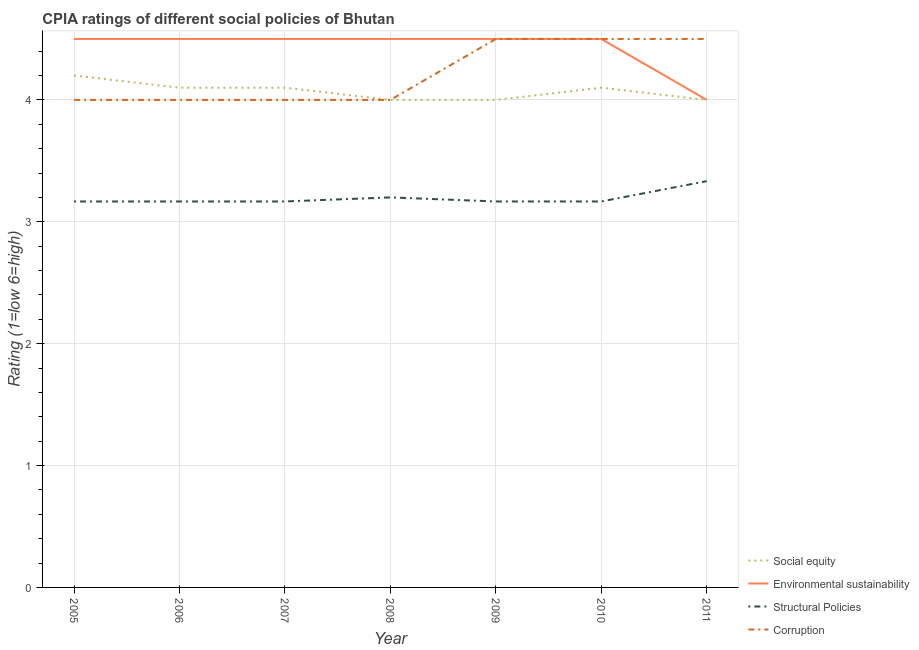How many different coloured lines are there?
Your response must be concise. 4. Does the line corresponding to cpia rating of environmental sustainability intersect with the line corresponding to cpia rating of social equity?
Your answer should be compact. Yes. Is the number of lines equal to the number of legend labels?
Offer a very short reply. Yes. What is the difference between the cpia rating of social equity in 2005 and that in 2009?
Your response must be concise. 0.2. What is the difference between the cpia rating of environmental sustainability in 2009 and the cpia rating of corruption in 2008?
Give a very brief answer. 0.5. What is the average cpia rating of structural policies per year?
Offer a very short reply. 3.2. In the year 2006, what is the difference between the cpia rating of social equity and cpia rating of environmental sustainability?
Your answer should be compact. -0.4. What is the difference between the highest and the second highest cpia rating of structural policies?
Give a very brief answer. 0.13. What is the difference between the highest and the lowest cpia rating of corruption?
Your answer should be compact. 0.5. In how many years, is the cpia rating of environmental sustainability greater than the average cpia rating of environmental sustainability taken over all years?
Provide a short and direct response. 6. Is it the case that in every year, the sum of the cpia rating of structural policies and cpia rating of environmental sustainability is greater than the sum of cpia rating of corruption and cpia rating of social equity?
Your answer should be compact. Yes. Is it the case that in every year, the sum of the cpia rating of social equity and cpia rating of environmental sustainability is greater than the cpia rating of structural policies?
Your response must be concise. Yes. Is the cpia rating of environmental sustainability strictly less than the cpia rating of social equity over the years?
Offer a terse response. No. How many lines are there?
Give a very brief answer. 4. How many years are there in the graph?
Your response must be concise. 7. How are the legend labels stacked?
Your answer should be very brief. Vertical. What is the title of the graph?
Provide a short and direct response. CPIA ratings of different social policies of Bhutan. Does "Public sector management" appear as one of the legend labels in the graph?
Your answer should be compact. No. What is the label or title of the X-axis?
Offer a terse response. Year. What is the label or title of the Y-axis?
Offer a terse response. Rating (1=low 6=high). What is the Rating (1=low 6=high) of Environmental sustainability in 2005?
Your answer should be very brief. 4.5. What is the Rating (1=low 6=high) of Structural Policies in 2005?
Offer a terse response. 3.17. What is the Rating (1=low 6=high) of Social equity in 2006?
Offer a terse response. 4.1. What is the Rating (1=low 6=high) in Environmental sustainability in 2006?
Provide a short and direct response. 4.5. What is the Rating (1=low 6=high) of Structural Policies in 2006?
Ensure brevity in your answer.  3.17. What is the Rating (1=low 6=high) in Corruption in 2006?
Your response must be concise. 4. What is the Rating (1=low 6=high) of Environmental sustainability in 2007?
Make the answer very short. 4.5. What is the Rating (1=low 6=high) of Structural Policies in 2007?
Provide a succinct answer. 3.17. What is the Rating (1=low 6=high) in Corruption in 2007?
Your answer should be compact. 4. What is the Rating (1=low 6=high) in Social equity in 2008?
Offer a terse response. 4. What is the Rating (1=low 6=high) in Environmental sustainability in 2008?
Offer a terse response. 4.5. What is the Rating (1=low 6=high) in Structural Policies in 2008?
Your response must be concise. 3.2. What is the Rating (1=low 6=high) in Structural Policies in 2009?
Keep it short and to the point. 3.17. What is the Rating (1=low 6=high) in Social equity in 2010?
Your answer should be very brief. 4.1. What is the Rating (1=low 6=high) in Environmental sustainability in 2010?
Your answer should be very brief. 4.5. What is the Rating (1=low 6=high) in Structural Policies in 2010?
Give a very brief answer. 3.17. What is the Rating (1=low 6=high) of Social equity in 2011?
Offer a very short reply. 4. What is the Rating (1=low 6=high) in Environmental sustainability in 2011?
Your response must be concise. 4. What is the Rating (1=low 6=high) in Structural Policies in 2011?
Provide a short and direct response. 3.33. Across all years, what is the maximum Rating (1=low 6=high) in Environmental sustainability?
Offer a very short reply. 4.5. Across all years, what is the maximum Rating (1=low 6=high) in Structural Policies?
Provide a succinct answer. 3.33. Across all years, what is the maximum Rating (1=low 6=high) in Corruption?
Offer a terse response. 4.5. Across all years, what is the minimum Rating (1=low 6=high) of Environmental sustainability?
Offer a terse response. 4. Across all years, what is the minimum Rating (1=low 6=high) in Structural Policies?
Ensure brevity in your answer.  3.17. What is the total Rating (1=low 6=high) in Social equity in the graph?
Your answer should be compact. 28.5. What is the total Rating (1=low 6=high) of Structural Policies in the graph?
Offer a terse response. 22.37. What is the total Rating (1=low 6=high) of Corruption in the graph?
Provide a short and direct response. 29.5. What is the difference between the Rating (1=low 6=high) of Social equity in 2005 and that in 2006?
Your answer should be very brief. 0.1. What is the difference between the Rating (1=low 6=high) of Environmental sustainability in 2005 and that in 2006?
Ensure brevity in your answer.  0. What is the difference between the Rating (1=low 6=high) of Corruption in 2005 and that in 2006?
Make the answer very short. 0. What is the difference between the Rating (1=low 6=high) in Social equity in 2005 and that in 2007?
Provide a short and direct response. 0.1. What is the difference between the Rating (1=low 6=high) of Environmental sustainability in 2005 and that in 2007?
Ensure brevity in your answer.  0. What is the difference between the Rating (1=low 6=high) in Structural Policies in 2005 and that in 2007?
Provide a short and direct response. 0. What is the difference between the Rating (1=low 6=high) of Social equity in 2005 and that in 2008?
Offer a very short reply. 0.2. What is the difference between the Rating (1=low 6=high) in Environmental sustainability in 2005 and that in 2008?
Give a very brief answer. 0. What is the difference between the Rating (1=low 6=high) in Structural Policies in 2005 and that in 2008?
Provide a succinct answer. -0.03. What is the difference between the Rating (1=low 6=high) in Structural Policies in 2005 and that in 2009?
Your answer should be compact. 0. What is the difference between the Rating (1=low 6=high) in Corruption in 2005 and that in 2009?
Your answer should be very brief. -0.5. What is the difference between the Rating (1=low 6=high) in Social equity in 2005 and that in 2011?
Ensure brevity in your answer.  0.2. What is the difference between the Rating (1=low 6=high) in Environmental sustainability in 2005 and that in 2011?
Offer a terse response. 0.5. What is the difference between the Rating (1=low 6=high) of Social equity in 2006 and that in 2007?
Offer a terse response. 0. What is the difference between the Rating (1=low 6=high) in Structural Policies in 2006 and that in 2008?
Ensure brevity in your answer.  -0.03. What is the difference between the Rating (1=low 6=high) in Corruption in 2006 and that in 2008?
Ensure brevity in your answer.  0. What is the difference between the Rating (1=low 6=high) of Social equity in 2006 and that in 2009?
Offer a very short reply. 0.1. What is the difference between the Rating (1=low 6=high) of Structural Policies in 2006 and that in 2009?
Your answer should be compact. 0. What is the difference between the Rating (1=low 6=high) in Corruption in 2006 and that in 2009?
Provide a short and direct response. -0.5. What is the difference between the Rating (1=low 6=high) in Environmental sustainability in 2006 and that in 2010?
Make the answer very short. 0. What is the difference between the Rating (1=low 6=high) in Structural Policies in 2006 and that in 2010?
Your answer should be compact. 0. What is the difference between the Rating (1=low 6=high) of Social equity in 2006 and that in 2011?
Your response must be concise. 0.1. What is the difference between the Rating (1=low 6=high) in Structural Policies in 2006 and that in 2011?
Give a very brief answer. -0.17. What is the difference between the Rating (1=low 6=high) in Social equity in 2007 and that in 2008?
Ensure brevity in your answer.  0.1. What is the difference between the Rating (1=low 6=high) of Structural Policies in 2007 and that in 2008?
Your answer should be compact. -0.03. What is the difference between the Rating (1=low 6=high) of Environmental sustainability in 2007 and that in 2009?
Provide a short and direct response. 0. What is the difference between the Rating (1=low 6=high) in Structural Policies in 2007 and that in 2009?
Provide a succinct answer. 0. What is the difference between the Rating (1=low 6=high) of Corruption in 2007 and that in 2009?
Your response must be concise. -0.5. What is the difference between the Rating (1=low 6=high) of Social equity in 2007 and that in 2010?
Ensure brevity in your answer.  0. What is the difference between the Rating (1=low 6=high) in Environmental sustainability in 2007 and that in 2010?
Offer a terse response. 0. What is the difference between the Rating (1=low 6=high) of Corruption in 2007 and that in 2011?
Keep it short and to the point. -0.5. What is the difference between the Rating (1=low 6=high) of Social equity in 2008 and that in 2009?
Your answer should be compact. 0. What is the difference between the Rating (1=low 6=high) in Structural Policies in 2008 and that in 2009?
Your response must be concise. 0.03. What is the difference between the Rating (1=low 6=high) in Environmental sustainability in 2008 and that in 2010?
Provide a succinct answer. 0. What is the difference between the Rating (1=low 6=high) of Social equity in 2008 and that in 2011?
Keep it short and to the point. 0. What is the difference between the Rating (1=low 6=high) in Environmental sustainability in 2008 and that in 2011?
Ensure brevity in your answer.  0.5. What is the difference between the Rating (1=low 6=high) in Structural Policies in 2008 and that in 2011?
Ensure brevity in your answer.  -0.13. What is the difference between the Rating (1=low 6=high) of Social equity in 2009 and that in 2010?
Provide a short and direct response. -0.1. What is the difference between the Rating (1=low 6=high) in Environmental sustainability in 2009 and that in 2010?
Give a very brief answer. 0. What is the difference between the Rating (1=low 6=high) of Structural Policies in 2009 and that in 2010?
Give a very brief answer. 0. What is the difference between the Rating (1=low 6=high) of Corruption in 2009 and that in 2010?
Ensure brevity in your answer.  0. What is the difference between the Rating (1=low 6=high) in Environmental sustainability in 2010 and that in 2011?
Your response must be concise. 0.5. What is the difference between the Rating (1=low 6=high) in Social equity in 2005 and the Rating (1=low 6=high) in Environmental sustainability in 2006?
Offer a very short reply. -0.3. What is the difference between the Rating (1=low 6=high) of Social equity in 2005 and the Rating (1=low 6=high) of Structural Policies in 2006?
Make the answer very short. 1.03. What is the difference between the Rating (1=low 6=high) of Environmental sustainability in 2005 and the Rating (1=low 6=high) of Corruption in 2006?
Offer a terse response. 0.5. What is the difference between the Rating (1=low 6=high) in Structural Policies in 2005 and the Rating (1=low 6=high) in Corruption in 2006?
Keep it short and to the point. -0.83. What is the difference between the Rating (1=low 6=high) in Social equity in 2005 and the Rating (1=low 6=high) in Structural Policies in 2008?
Offer a very short reply. 1. What is the difference between the Rating (1=low 6=high) of Structural Policies in 2005 and the Rating (1=low 6=high) of Corruption in 2008?
Provide a succinct answer. -0.83. What is the difference between the Rating (1=low 6=high) in Social equity in 2005 and the Rating (1=low 6=high) in Structural Policies in 2009?
Ensure brevity in your answer.  1.03. What is the difference between the Rating (1=low 6=high) in Environmental sustainability in 2005 and the Rating (1=low 6=high) in Structural Policies in 2009?
Provide a succinct answer. 1.33. What is the difference between the Rating (1=low 6=high) in Structural Policies in 2005 and the Rating (1=low 6=high) in Corruption in 2009?
Your answer should be compact. -1.33. What is the difference between the Rating (1=low 6=high) in Social equity in 2005 and the Rating (1=low 6=high) in Corruption in 2010?
Give a very brief answer. -0.3. What is the difference between the Rating (1=low 6=high) in Environmental sustainability in 2005 and the Rating (1=low 6=high) in Corruption in 2010?
Keep it short and to the point. 0. What is the difference between the Rating (1=low 6=high) of Structural Policies in 2005 and the Rating (1=low 6=high) of Corruption in 2010?
Offer a very short reply. -1.33. What is the difference between the Rating (1=low 6=high) in Social equity in 2005 and the Rating (1=low 6=high) in Structural Policies in 2011?
Provide a succinct answer. 0.87. What is the difference between the Rating (1=low 6=high) of Structural Policies in 2005 and the Rating (1=low 6=high) of Corruption in 2011?
Offer a terse response. -1.33. What is the difference between the Rating (1=low 6=high) in Social equity in 2006 and the Rating (1=low 6=high) in Structural Policies in 2007?
Your answer should be compact. 0.93. What is the difference between the Rating (1=low 6=high) in Social equity in 2006 and the Rating (1=low 6=high) in Corruption in 2007?
Give a very brief answer. 0.1. What is the difference between the Rating (1=low 6=high) in Environmental sustainability in 2006 and the Rating (1=low 6=high) in Structural Policies in 2007?
Give a very brief answer. 1.33. What is the difference between the Rating (1=low 6=high) of Social equity in 2006 and the Rating (1=low 6=high) of Corruption in 2009?
Offer a very short reply. -0.4. What is the difference between the Rating (1=low 6=high) in Structural Policies in 2006 and the Rating (1=low 6=high) in Corruption in 2009?
Offer a very short reply. -1.33. What is the difference between the Rating (1=low 6=high) in Social equity in 2006 and the Rating (1=low 6=high) in Environmental sustainability in 2010?
Offer a very short reply. -0.4. What is the difference between the Rating (1=low 6=high) of Social equity in 2006 and the Rating (1=low 6=high) of Structural Policies in 2010?
Keep it short and to the point. 0.93. What is the difference between the Rating (1=low 6=high) in Social equity in 2006 and the Rating (1=low 6=high) in Corruption in 2010?
Provide a short and direct response. -0.4. What is the difference between the Rating (1=low 6=high) of Environmental sustainability in 2006 and the Rating (1=low 6=high) of Structural Policies in 2010?
Your response must be concise. 1.33. What is the difference between the Rating (1=low 6=high) in Structural Policies in 2006 and the Rating (1=low 6=high) in Corruption in 2010?
Your answer should be very brief. -1.33. What is the difference between the Rating (1=low 6=high) of Social equity in 2006 and the Rating (1=low 6=high) of Environmental sustainability in 2011?
Give a very brief answer. 0.1. What is the difference between the Rating (1=low 6=high) in Social equity in 2006 and the Rating (1=low 6=high) in Structural Policies in 2011?
Offer a very short reply. 0.77. What is the difference between the Rating (1=low 6=high) in Environmental sustainability in 2006 and the Rating (1=low 6=high) in Structural Policies in 2011?
Provide a short and direct response. 1.17. What is the difference between the Rating (1=low 6=high) in Structural Policies in 2006 and the Rating (1=low 6=high) in Corruption in 2011?
Give a very brief answer. -1.33. What is the difference between the Rating (1=low 6=high) in Social equity in 2007 and the Rating (1=low 6=high) in Structural Policies in 2008?
Offer a terse response. 0.9. What is the difference between the Rating (1=low 6=high) in Social equity in 2007 and the Rating (1=low 6=high) in Corruption in 2008?
Make the answer very short. 0.1. What is the difference between the Rating (1=low 6=high) in Environmental sustainability in 2007 and the Rating (1=low 6=high) in Corruption in 2009?
Offer a very short reply. 0. What is the difference between the Rating (1=low 6=high) of Structural Policies in 2007 and the Rating (1=low 6=high) of Corruption in 2009?
Provide a short and direct response. -1.33. What is the difference between the Rating (1=low 6=high) of Structural Policies in 2007 and the Rating (1=low 6=high) of Corruption in 2010?
Your answer should be very brief. -1.33. What is the difference between the Rating (1=low 6=high) in Social equity in 2007 and the Rating (1=low 6=high) in Environmental sustainability in 2011?
Your answer should be very brief. 0.1. What is the difference between the Rating (1=low 6=high) in Social equity in 2007 and the Rating (1=low 6=high) in Structural Policies in 2011?
Your answer should be compact. 0.77. What is the difference between the Rating (1=low 6=high) in Social equity in 2007 and the Rating (1=low 6=high) in Corruption in 2011?
Provide a succinct answer. -0.4. What is the difference between the Rating (1=low 6=high) in Structural Policies in 2007 and the Rating (1=low 6=high) in Corruption in 2011?
Give a very brief answer. -1.33. What is the difference between the Rating (1=low 6=high) of Social equity in 2008 and the Rating (1=low 6=high) of Structural Policies in 2009?
Provide a short and direct response. 0.83. What is the difference between the Rating (1=low 6=high) of Environmental sustainability in 2008 and the Rating (1=low 6=high) of Corruption in 2009?
Provide a short and direct response. 0. What is the difference between the Rating (1=low 6=high) in Structural Policies in 2008 and the Rating (1=low 6=high) in Corruption in 2009?
Offer a terse response. -1.3. What is the difference between the Rating (1=low 6=high) in Social equity in 2008 and the Rating (1=low 6=high) in Structural Policies in 2010?
Provide a succinct answer. 0.83. What is the difference between the Rating (1=low 6=high) of Social equity in 2008 and the Rating (1=low 6=high) of Corruption in 2010?
Your response must be concise. -0.5. What is the difference between the Rating (1=low 6=high) of Social equity in 2008 and the Rating (1=low 6=high) of Environmental sustainability in 2011?
Offer a very short reply. 0. What is the difference between the Rating (1=low 6=high) in Social equity in 2008 and the Rating (1=low 6=high) in Structural Policies in 2011?
Your answer should be compact. 0.67. What is the difference between the Rating (1=low 6=high) of Social equity in 2009 and the Rating (1=low 6=high) of Environmental sustainability in 2010?
Offer a very short reply. -0.5. What is the difference between the Rating (1=low 6=high) in Social equity in 2009 and the Rating (1=low 6=high) in Structural Policies in 2010?
Provide a short and direct response. 0.83. What is the difference between the Rating (1=low 6=high) of Structural Policies in 2009 and the Rating (1=low 6=high) of Corruption in 2010?
Keep it short and to the point. -1.33. What is the difference between the Rating (1=low 6=high) in Social equity in 2009 and the Rating (1=low 6=high) in Environmental sustainability in 2011?
Your answer should be very brief. 0. What is the difference between the Rating (1=low 6=high) in Social equity in 2009 and the Rating (1=low 6=high) in Structural Policies in 2011?
Your answer should be very brief. 0.67. What is the difference between the Rating (1=low 6=high) of Environmental sustainability in 2009 and the Rating (1=low 6=high) of Structural Policies in 2011?
Provide a short and direct response. 1.17. What is the difference between the Rating (1=low 6=high) in Structural Policies in 2009 and the Rating (1=low 6=high) in Corruption in 2011?
Offer a terse response. -1.33. What is the difference between the Rating (1=low 6=high) in Social equity in 2010 and the Rating (1=low 6=high) in Structural Policies in 2011?
Provide a short and direct response. 0.77. What is the difference between the Rating (1=low 6=high) in Social equity in 2010 and the Rating (1=low 6=high) in Corruption in 2011?
Provide a succinct answer. -0.4. What is the difference between the Rating (1=low 6=high) of Environmental sustainability in 2010 and the Rating (1=low 6=high) of Corruption in 2011?
Offer a terse response. 0. What is the difference between the Rating (1=low 6=high) in Structural Policies in 2010 and the Rating (1=low 6=high) in Corruption in 2011?
Keep it short and to the point. -1.33. What is the average Rating (1=low 6=high) in Social equity per year?
Provide a succinct answer. 4.07. What is the average Rating (1=low 6=high) of Environmental sustainability per year?
Keep it short and to the point. 4.43. What is the average Rating (1=low 6=high) in Structural Policies per year?
Give a very brief answer. 3.2. What is the average Rating (1=low 6=high) of Corruption per year?
Give a very brief answer. 4.21. In the year 2005, what is the difference between the Rating (1=low 6=high) in Social equity and Rating (1=low 6=high) in Structural Policies?
Offer a terse response. 1.03. In the year 2006, what is the difference between the Rating (1=low 6=high) of Social equity and Rating (1=low 6=high) of Environmental sustainability?
Provide a short and direct response. -0.4. In the year 2006, what is the difference between the Rating (1=low 6=high) of Social equity and Rating (1=low 6=high) of Structural Policies?
Ensure brevity in your answer.  0.93. In the year 2006, what is the difference between the Rating (1=low 6=high) in Social equity and Rating (1=low 6=high) in Corruption?
Offer a very short reply. 0.1. In the year 2006, what is the difference between the Rating (1=low 6=high) of Structural Policies and Rating (1=low 6=high) of Corruption?
Give a very brief answer. -0.83. In the year 2007, what is the difference between the Rating (1=low 6=high) of Environmental sustainability and Rating (1=low 6=high) of Structural Policies?
Make the answer very short. 1.33. In the year 2008, what is the difference between the Rating (1=low 6=high) of Social equity and Rating (1=low 6=high) of Structural Policies?
Your answer should be compact. 0.8. In the year 2008, what is the difference between the Rating (1=low 6=high) in Social equity and Rating (1=low 6=high) in Corruption?
Keep it short and to the point. 0. In the year 2008, what is the difference between the Rating (1=low 6=high) in Environmental sustainability and Rating (1=low 6=high) in Structural Policies?
Your answer should be very brief. 1.3. In the year 2008, what is the difference between the Rating (1=low 6=high) in Structural Policies and Rating (1=low 6=high) in Corruption?
Offer a terse response. -0.8. In the year 2009, what is the difference between the Rating (1=low 6=high) in Social equity and Rating (1=low 6=high) in Environmental sustainability?
Offer a very short reply. -0.5. In the year 2009, what is the difference between the Rating (1=low 6=high) in Social equity and Rating (1=low 6=high) in Structural Policies?
Ensure brevity in your answer.  0.83. In the year 2009, what is the difference between the Rating (1=low 6=high) in Environmental sustainability and Rating (1=low 6=high) in Structural Policies?
Give a very brief answer. 1.33. In the year 2009, what is the difference between the Rating (1=low 6=high) in Structural Policies and Rating (1=low 6=high) in Corruption?
Keep it short and to the point. -1.33. In the year 2010, what is the difference between the Rating (1=low 6=high) in Social equity and Rating (1=low 6=high) in Structural Policies?
Provide a succinct answer. 0.93. In the year 2010, what is the difference between the Rating (1=low 6=high) in Environmental sustainability and Rating (1=low 6=high) in Structural Policies?
Offer a terse response. 1.33. In the year 2010, what is the difference between the Rating (1=low 6=high) of Structural Policies and Rating (1=low 6=high) of Corruption?
Offer a terse response. -1.33. In the year 2011, what is the difference between the Rating (1=low 6=high) in Environmental sustainability and Rating (1=low 6=high) in Corruption?
Keep it short and to the point. -0.5. In the year 2011, what is the difference between the Rating (1=low 6=high) in Structural Policies and Rating (1=low 6=high) in Corruption?
Give a very brief answer. -1.17. What is the ratio of the Rating (1=low 6=high) in Social equity in 2005 to that in 2006?
Keep it short and to the point. 1.02. What is the ratio of the Rating (1=low 6=high) in Environmental sustainability in 2005 to that in 2006?
Keep it short and to the point. 1. What is the ratio of the Rating (1=low 6=high) of Corruption in 2005 to that in 2006?
Make the answer very short. 1. What is the ratio of the Rating (1=low 6=high) of Social equity in 2005 to that in 2007?
Your answer should be very brief. 1.02. What is the ratio of the Rating (1=low 6=high) in Environmental sustainability in 2005 to that in 2007?
Offer a terse response. 1. What is the ratio of the Rating (1=low 6=high) of Structural Policies in 2005 to that in 2007?
Provide a succinct answer. 1. What is the ratio of the Rating (1=low 6=high) in Corruption in 2005 to that in 2008?
Your answer should be compact. 1. What is the ratio of the Rating (1=low 6=high) of Structural Policies in 2005 to that in 2009?
Your response must be concise. 1. What is the ratio of the Rating (1=low 6=high) of Social equity in 2005 to that in 2010?
Offer a terse response. 1.02. What is the ratio of the Rating (1=low 6=high) of Environmental sustainability in 2005 to that in 2010?
Your response must be concise. 1. What is the ratio of the Rating (1=low 6=high) of Structural Policies in 2005 to that in 2010?
Provide a succinct answer. 1. What is the ratio of the Rating (1=low 6=high) in Corruption in 2005 to that in 2010?
Ensure brevity in your answer.  0.89. What is the ratio of the Rating (1=low 6=high) of Social equity in 2005 to that in 2011?
Offer a very short reply. 1.05. What is the ratio of the Rating (1=low 6=high) in Structural Policies in 2005 to that in 2011?
Offer a very short reply. 0.95. What is the ratio of the Rating (1=low 6=high) in Corruption in 2005 to that in 2011?
Ensure brevity in your answer.  0.89. What is the ratio of the Rating (1=low 6=high) of Social equity in 2006 to that in 2007?
Provide a short and direct response. 1. What is the ratio of the Rating (1=low 6=high) in Environmental sustainability in 2006 to that in 2007?
Offer a very short reply. 1. What is the ratio of the Rating (1=low 6=high) in Corruption in 2006 to that in 2007?
Provide a short and direct response. 1. What is the ratio of the Rating (1=low 6=high) of Corruption in 2006 to that in 2008?
Your response must be concise. 1. What is the ratio of the Rating (1=low 6=high) of Environmental sustainability in 2006 to that in 2009?
Make the answer very short. 1. What is the ratio of the Rating (1=low 6=high) in Structural Policies in 2006 to that in 2009?
Ensure brevity in your answer.  1. What is the ratio of the Rating (1=low 6=high) in Corruption in 2006 to that in 2009?
Offer a terse response. 0.89. What is the ratio of the Rating (1=low 6=high) of Social equity in 2006 to that in 2011?
Ensure brevity in your answer.  1.02. What is the ratio of the Rating (1=low 6=high) in Environmental sustainability in 2006 to that in 2011?
Offer a very short reply. 1.12. What is the ratio of the Rating (1=low 6=high) of Corruption in 2006 to that in 2011?
Provide a short and direct response. 0.89. What is the ratio of the Rating (1=low 6=high) of Social equity in 2007 to that in 2008?
Your answer should be compact. 1.02. What is the ratio of the Rating (1=low 6=high) of Environmental sustainability in 2007 to that in 2008?
Keep it short and to the point. 1. What is the ratio of the Rating (1=low 6=high) in Corruption in 2007 to that in 2008?
Keep it short and to the point. 1. What is the ratio of the Rating (1=low 6=high) of Social equity in 2007 to that in 2009?
Your response must be concise. 1.02. What is the ratio of the Rating (1=low 6=high) in Environmental sustainability in 2007 to that in 2009?
Make the answer very short. 1. What is the ratio of the Rating (1=low 6=high) of Structural Policies in 2007 to that in 2009?
Offer a very short reply. 1. What is the ratio of the Rating (1=low 6=high) in Structural Policies in 2007 to that in 2010?
Provide a succinct answer. 1. What is the ratio of the Rating (1=low 6=high) in Social equity in 2007 to that in 2011?
Your response must be concise. 1.02. What is the ratio of the Rating (1=low 6=high) of Environmental sustainability in 2007 to that in 2011?
Offer a terse response. 1.12. What is the ratio of the Rating (1=low 6=high) in Structural Policies in 2007 to that in 2011?
Your answer should be compact. 0.95. What is the ratio of the Rating (1=low 6=high) of Social equity in 2008 to that in 2009?
Your response must be concise. 1. What is the ratio of the Rating (1=low 6=high) in Environmental sustainability in 2008 to that in 2009?
Your answer should be compact. 1. What is the ratio of the Rating (1=low 6=high) in Structural Policies in 2008 to that in 2009?
Provide a succinct answer. 1.01. What is the ratio of the Rating (1=low 6=high) of Social equity in 2008 to that in 2010?
Offer a terse response. 0.98. What is the ratio of the Rating (1=low 6=high) in Environmental sustainability in 2008 to that in 2010?
Ensure brevity in your answer.  1. What is the ratio of the Rating (1=low 6=high) in Structural Policies in 2008 to that in 2010?
Give a very brief answer. 1.01. What is the ratio of the Rating (1=low 6=high) of Social equity in 2009 to that in 2010?
Your answer should be compact. 0.98. What is the ratio of the Rating (1=low 6=high) in Structural Policies in 2009 to that in 2010?
Your answer should be compact. 1. What is the ratio of the Rating (1=low 6=high) in Social equity in 2009 to that in 2011?
Provide a short and direct response. 1. What is the ratio of the Rating (1=low 6=high) in Environmental sustainability in 2009 to that in 2011?
Provide a succinct answer. 1.12. What is the ratio of the Rating (1=low 6=high) of Corruption in 2009 to that in 2011?
Make the answer very short. 1. What is the ratio of the Rating (1=low 6=high) of Social equity in 2010 to that in 2011?
Ensure brevity in your answer.  1.02. What is the difference between the highest and the second highest Rating (1=low 6=high) in Environmental sustainability?
Give a very brief answer. 0. What is the difference between the highest and the second highest Rating (1=low 6=high) in Structural Policies?
Your answer should be compact. 0.13. What is the difference between the highest and the second highest Rating (1=low 6=high) in Corruption?
Your answer should be very brief. 0. What is the difference between the highest and the lowest Rating (1=low 6=high) of Corruption?
Offer a terse response. 0.5. 